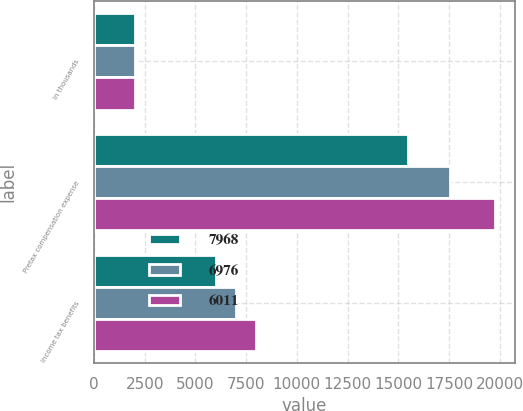Convert chart. <chart><loc_0><loc_0><loc_500><loc_500><stacked_bar_chart><ecel><fcel>in thousands<fcel>Pretax compensation expense<fcel>Income tax benefits<nl><fcel>7968<fcel>2012<fcel>15491<fcel>6011<nl><fcel>6976<fcel>2011<fcel>17537<fcel>6976<nl><fcel>6011<fcel>2010<fcel>19746<fcel>7968<nl></chart> 